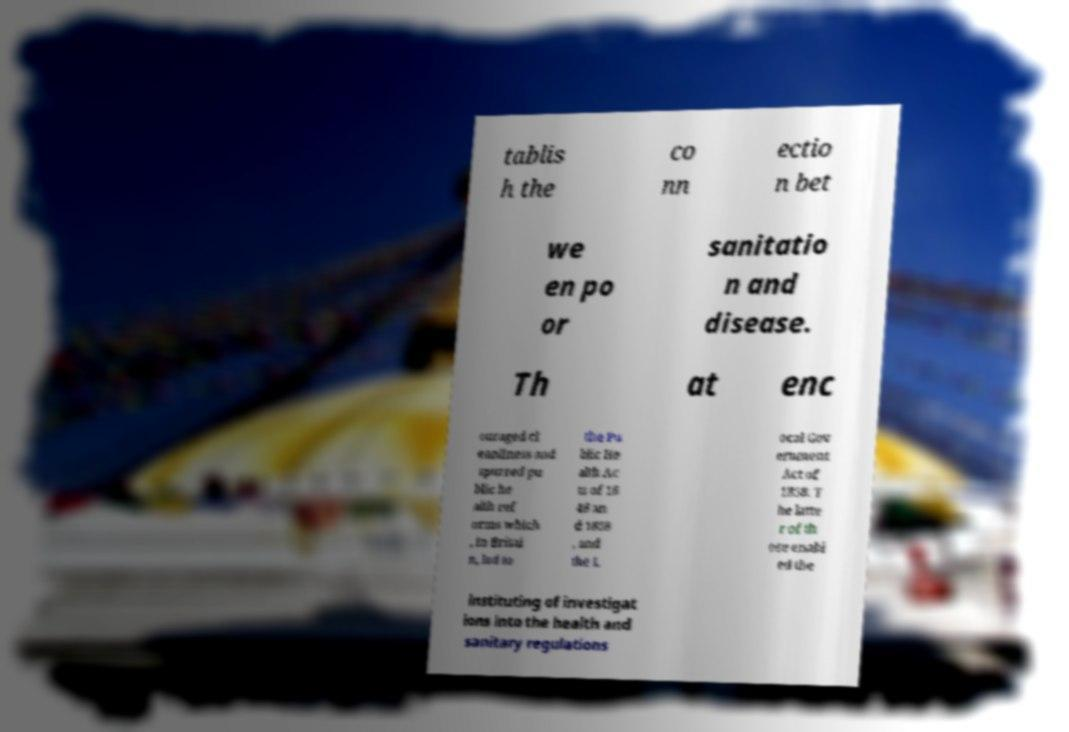Please identify and transcribe the text found in this image. tablis h the co nn ectio n bet we en po or sanitatio n and disease. Th at enc ouraged cl eanliness and spurred pu blic he alth ref orms which , in Britai n, led to the Pu blic He alth Ac ts of 18 48 an d 1858 , and the L ocal Gov ernment Act of 1858. T he latte r of th ose enabl ed the instituting of investigat ions into the health and sanitary regulations 